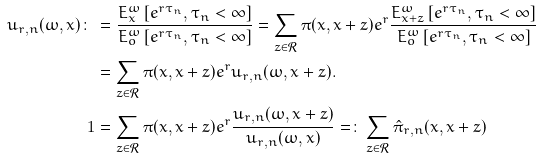<formula> <loc_0><loc_0><loc_500><loc_500>u _ { r , n } ( \omega , x ) \colon \, & = \frac { E _ { x } ^ { \omega } \left [ e ^ { r \tau _ { n } } , \tau _ { n } < \infty \right ] } { E _ { o } ^ { \omega } \left [ e ^ { r \tau _ { n } } , \tau _ { n } < \infty \right ] } = \sum _ { z \in \mathcal { R } } \pi ( x , x + z ) e ^ { r } \frac { E _ { x + z } ^ { \omega } \left [ e ^ { r \tau _ { n } } , \tau _ { n } < \infty \right ] } { E _ { o } ^ { \omega } \left [ e ^ { r \tau _ { n } } , \tau _ { n } < \infty \right ] } \\ & = \sum _ { z \in \mathcal { R } } \pi ( x , x + z ) e ^ { r } u _ { r , n } ( \omega , x + z ) . \\ 1 & = \sum _ { z \in \mathcal { R } } \pi ( x , x + z ) e ^ { r } \frac { u _ { r , n } ( \omega , x + z ) } { u _ { r , n } ( \omega , x ) } = \colon \sum _ { z \in \mathcal { R } } \hat { \pi } _ { r , n } ( x , x + z )</formula> 